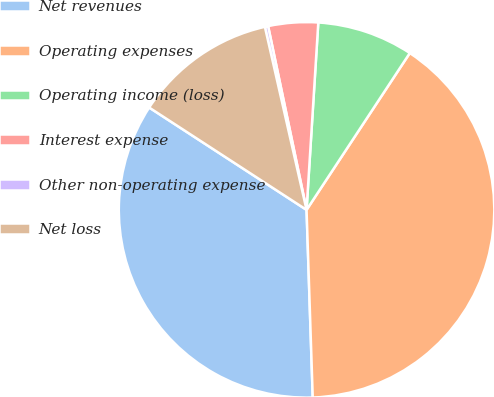Convert chart. <chart><loc_0><loc_0><loc_500><loc_500><pie_chart><fcel>Net revenues<fcel>Operating expenses<fcel>Operating income (loss)<fcel>Interest expense<fcel>Other non-operating expense<fcel>Net loss<nl><fcel>34.7%<fcel>40.21%<fcel>8.27%<fcel>4.28%<fcel>0.28%<fcel>12.26%<nl></chart> 